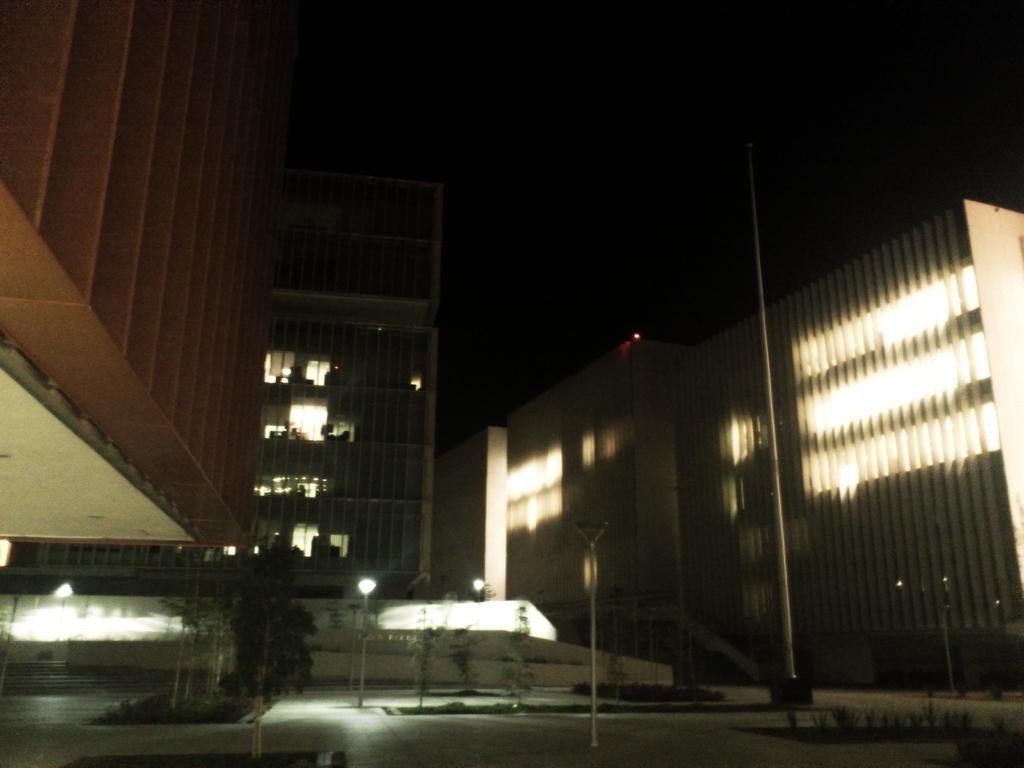What is located in the foreground of the image? There is a road and trees in the foreground of the image. What structure can be seen in the middle of the image? There is a building in the middle of the image. What is visible at the top of the image? The sky is visible at the top of the image. How would you describe the sky in the image? The sky appears to be dark in the image. What type of reward is being given to the road in the image? There is no reward being given to the road in the image; it is simply a part of the landscape. What type of camera is being used to capture the image? The type of camera used to capture the image is not mentioned in the image or the provided facts, so it cannot be determined. 